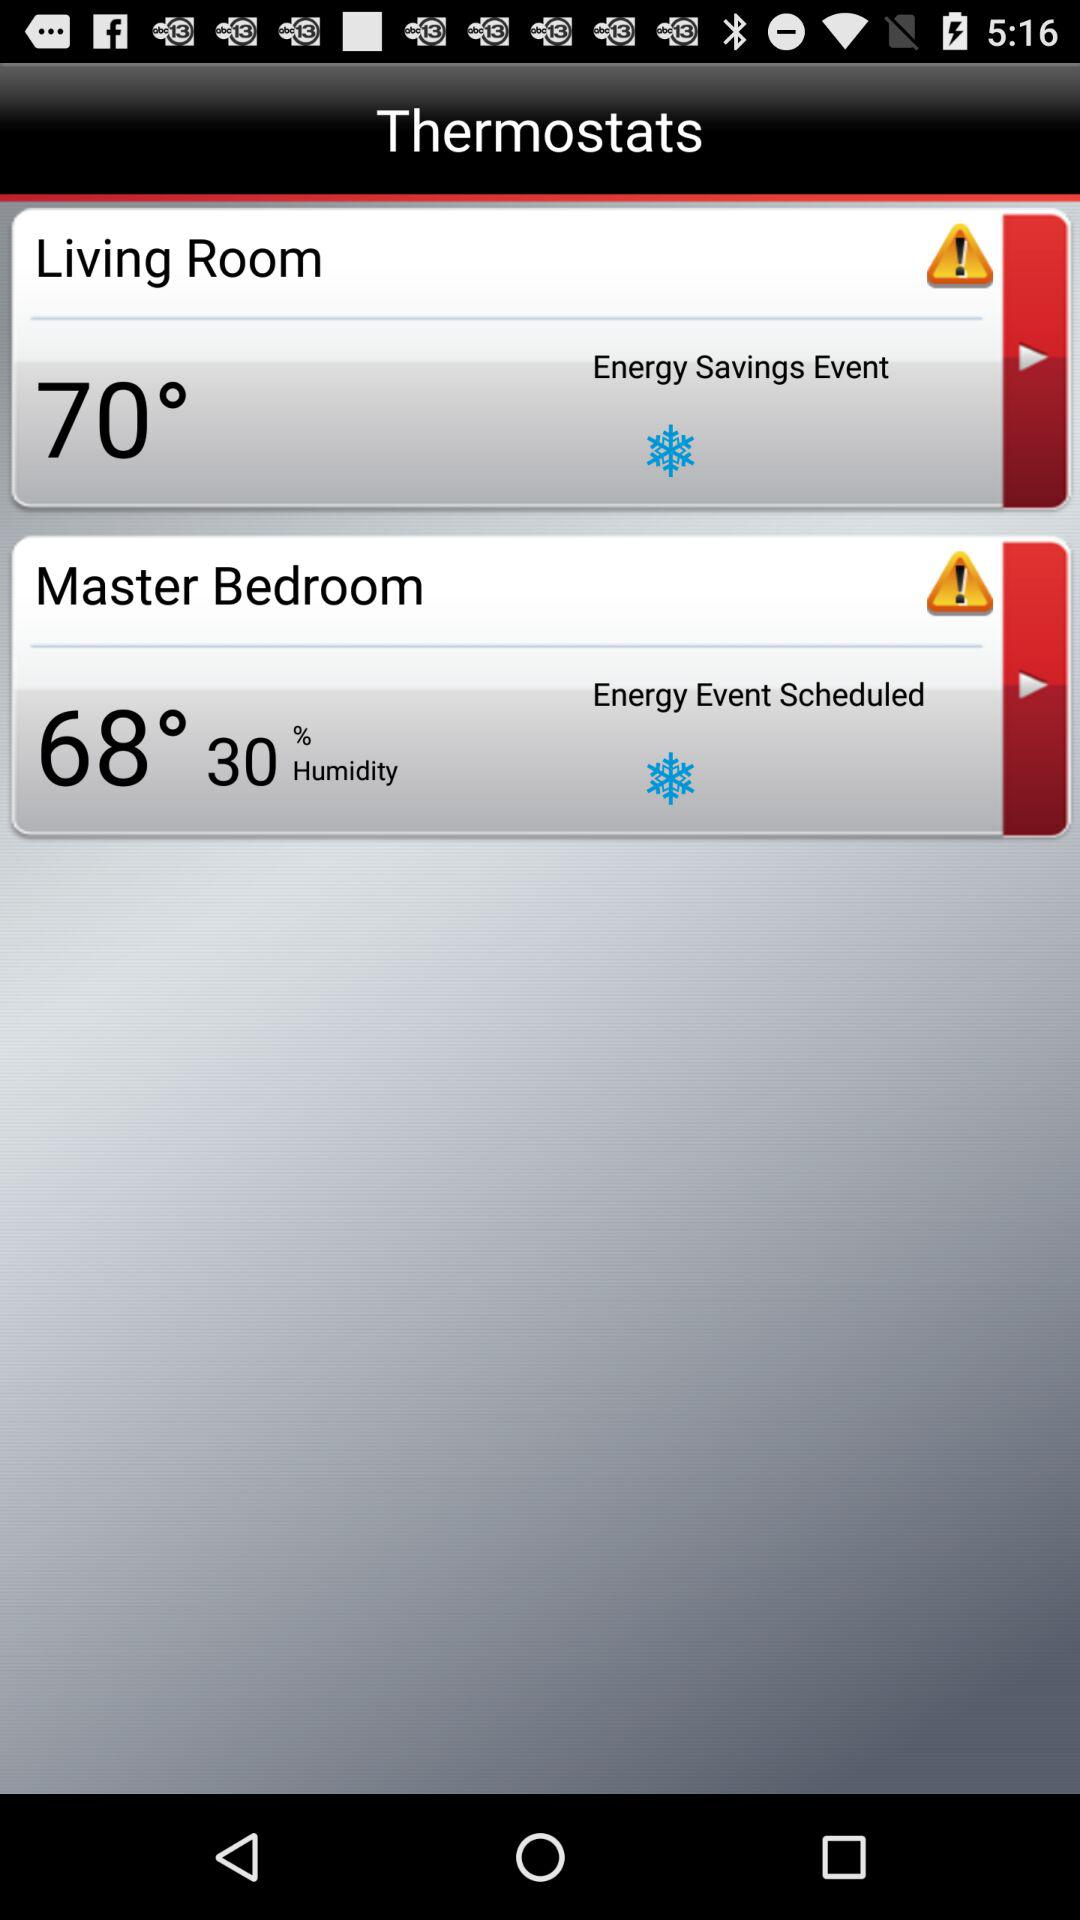How many thermostats are there?
Answer the question using a single word or phrase. 2 